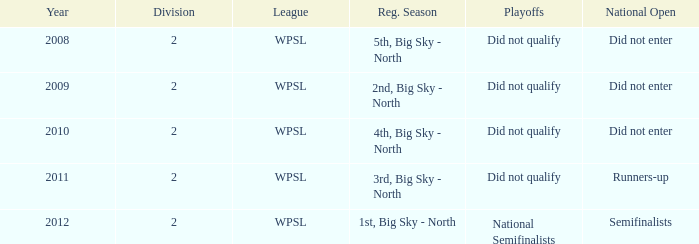What league was involved in 2010? WPSL. 